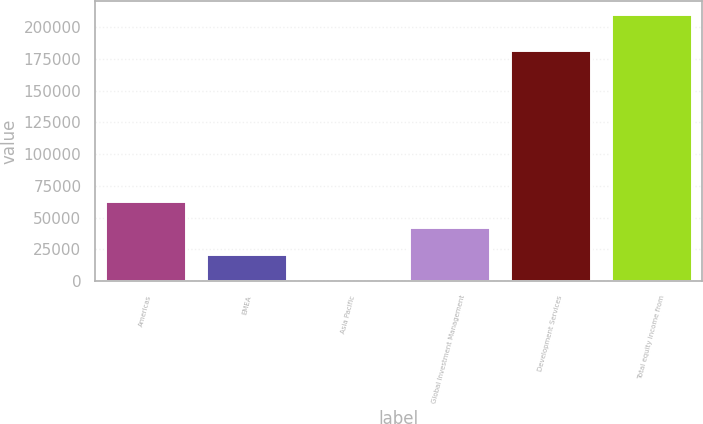<chart> <loc_0><loc_0><loc_500><loc_500><bar_chart><fcel>Americas<fcel>EMEA<fcel>Asia Pacific<fcel>Global Investment Management<fcel>Development Services<fcel>Total equity income from<nl><fcel>63340<fcel>21378<fcel>397<fcel>42359<fcel>181545<fcel>210207<nl></chart> 